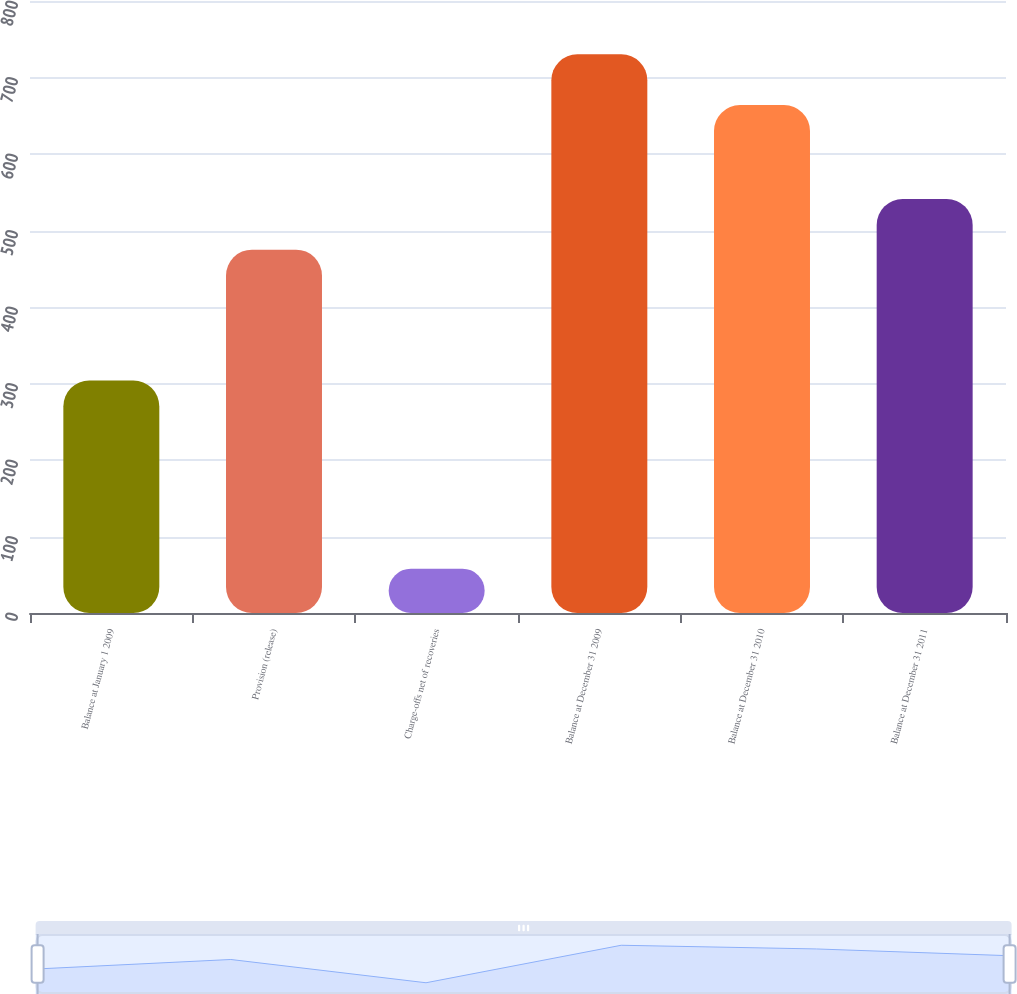Convert chart. <chart><loc_0><loc_0><loc_500><loc_500><bar_chart><fcel>Balance at January 1 2009<fcel>Provision (release)<fcel>Charge-offs net of recoveries<fcel>Balance at December 31 2009<fcel>Balance at December 31 2010<fcel>Balance at December 31 2011<nl><fcel>304<fcel>475<fcel>58<fcel>730.3<fcel>664<fcel>541.3<nl></chart> 